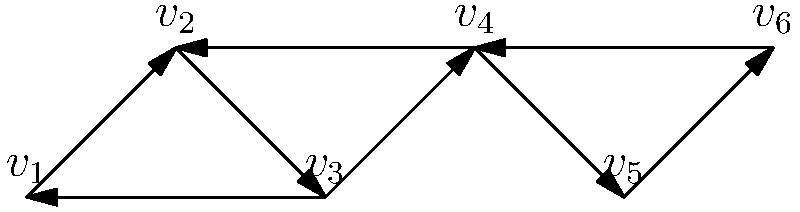In a microservices architecture, dependencies between services are represented by a directed graph. Each vertex represents a microservice, and each edge represents a dependency. Identify the number of strongly connected components in the given graph and list the services (vertices) in each component. To find strongly connected components (SCCs) in a directed graph, we can use Kosaraju's algorithm. The steps are:

1. Perform a depth-first search (DFS) on the original graph to compute finishing times for each vertex.
2. Create the transpose of the graph (reverse all edge directions).
3. Perform a DFS on the transposed graph, starting with the vertex that has the highest finishing time.

Let's apply this to our graph:

Step 1: DFS on original graph
- Start at $v_1$: $v_1 \rightarrow v_2 \rightarrow v_3 \rightarrow v_4 \rightarrow v_5 \rightarrow v_6$
Finishing times: $v_6$ (1), $v_5$ (2), $v_4$ (3), $v_3$ (4), $v_2$ (5), $v_1$ (6)

Step 2: Create transpose (already done mentally)

Step 3: DFS on transposed graph
- Start at $v_1$: $v_1$
- Start at $v_2$: $v_2 \rightarrow v_1 \rightarrow v_3$
- Start at $v_4$: $v_4 \rightarrow v_3 \rightarrow v_2 \rightarrow v_5 \rightarrow v_6$

This gives us the strongly connected components:
1. $\{v_1, v_2, v_3\}$
2. $\{v_4, v_5, v_6\}$

Therefore, there are 2 strongly connected components in the graph.
Answer: 2 SCCs: $\{v_1, v_2, v_3\}$ and $\{v_4, v_5, v_6\}$ 